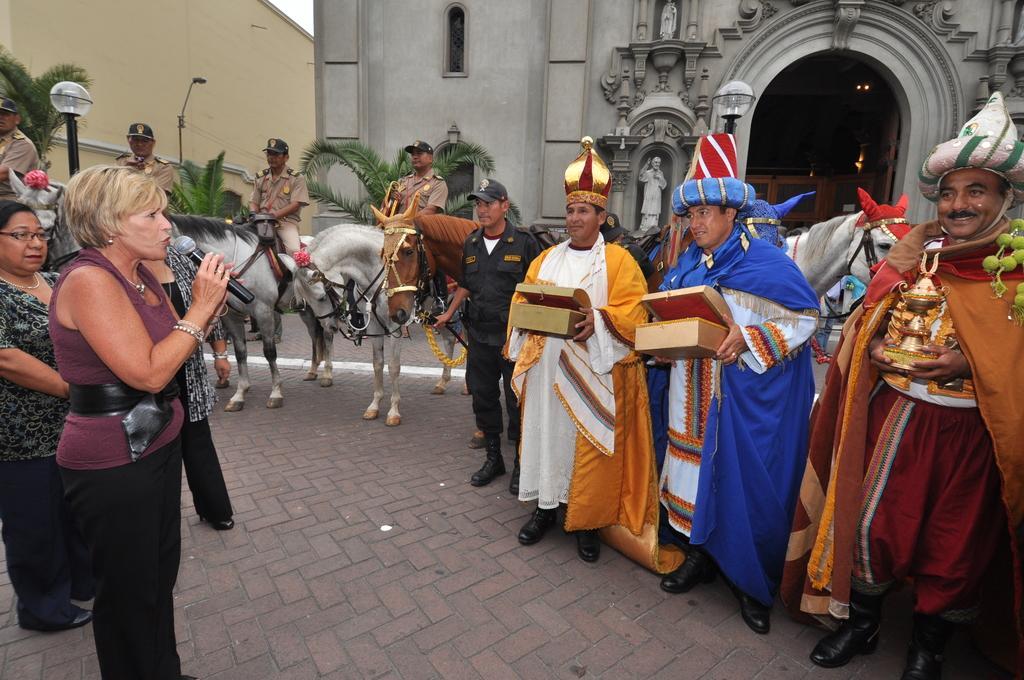Describe this image in one or two sentences. In this picture there is a woman standing and holding a mic. There are four persons sitting on a horse. There are three people holding boxes in their hands. There is a person standing. There is a streetlight and church at the background. 